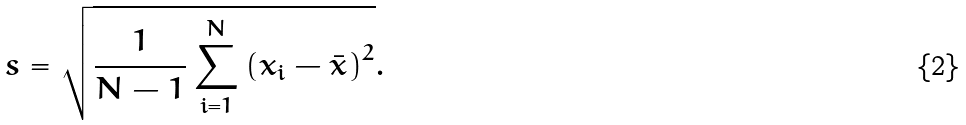<formula> <loc_0><loc_0><loc_500><loc_500>s = { \sqrt { { \frac { 1 } { N - 1 } } \sum _ { i = 1 } ^ { N } \left ( x _ { i } - { \bar { x } } \right ) ^ { 2 } } } .</formula> 